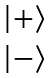Convert formula to latex. <formula><loc_0><loc_0><loc_500><loc_500>\begin{matrix} \left | + \right \rangle \\ \left | - \right \rangle \\ \end{matrix}</formula> 